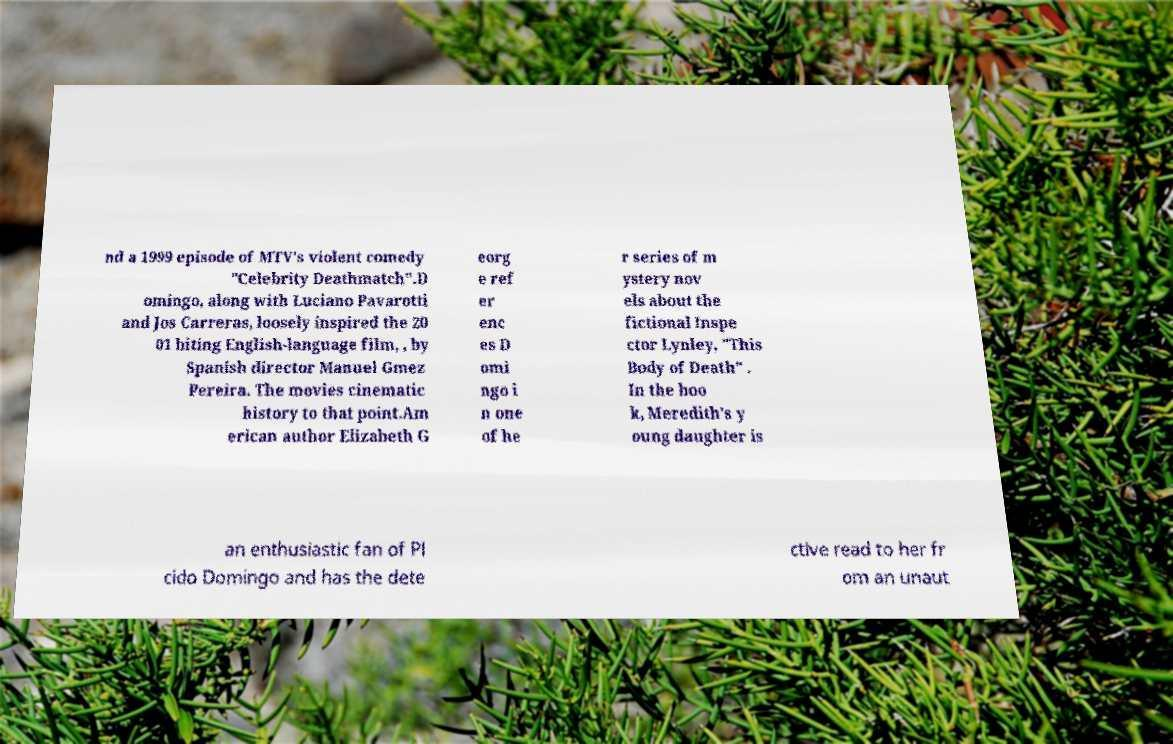Could you extract and type out the text from this image? nd a 1999 episode of MTV's violent comedy "Celebrity Deathmatch".D omingo, along with Luciano Pavarotti and Jos Carreras, loosely inspired the 20 01 biting English-language film, , by Spanish director Manuel Gmez Pereira. The movies cinematic history to that point.Am erican author Elizabeth G eorg e ref er enc es D omi ngo i n one of he r series of m ystery nov els about the fictional Inspe ctor Lynley, "This Body of Death" . In the boo k, Meredith's y oung daughter is an enthusiastic fan of Pl cido Domingo and has the dete ctive read to her fr om an unaut 